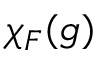<formula> <loc_0><loc_0><loc_500><loc_500>\chi _ { F } ( g )</formula> 